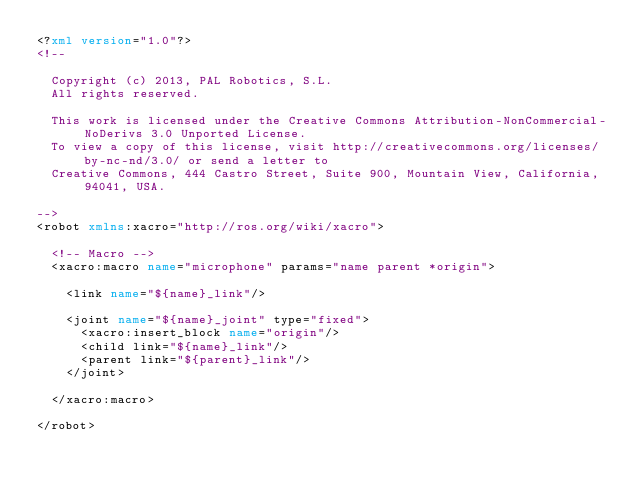<code> <loc_0><loc_0><loc_500><loc_500><_XML_><?xml version="1.0"?>
<!--

  Copyright (c) 2013, PAL Robotics, S.L.
  All rights reserved.

  This work is licensed under the Creative Commons Attribution-NonCommercial-NoDerivs 3.0 Unported License.
  To view a copy of this license, visit http://creativecommons.org/licenses/by-nc-nd/3.0/ or send a letter to
  Creative Commons, 444 Castro Street, Suite 900, Mountain View, California, 94041, USA.

-->
<robot xmlns:xacro="http://ros.org/wiki/xacro">

  <!-- Macro -->
  <xacro:macro name="microphone" params="name parent *origin">

    <link name="${name}_link"/>

    <joint name="${name}_joint" type="fixed">
      <xacro:insert_block name="origin"/>
      <child link="${name}_link"/>
      <parent link="${parent}_link"/>
    </joint>

  </xacro:macro>

</robot>
</code> 